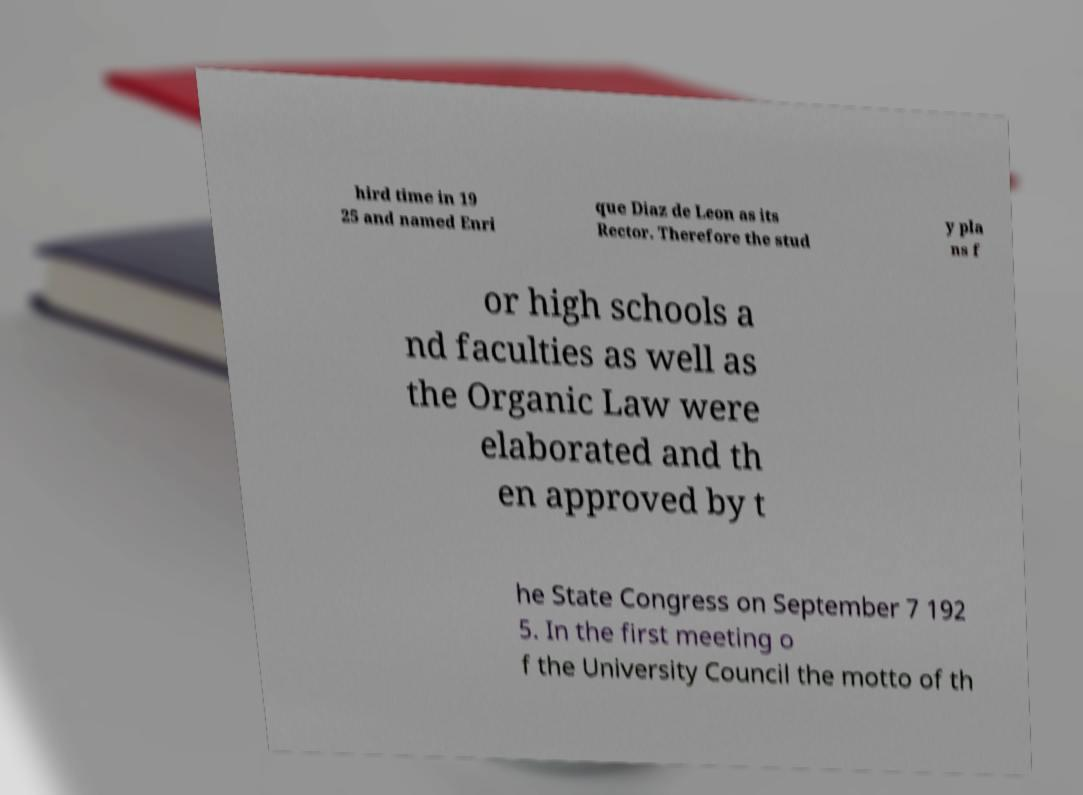For documentation purposes, I need the text within this image transcribed. Could you provide that? hird time in 19 25 and named Enri que Diaz de Leon as its Rector. Therefore the stud y pla ns f or high schools a nd faculties as well as the Organic Law were elaborated and th en approved by t he State Congress on September 7 192 5. In the first meeting o f the University Council the motto of th 